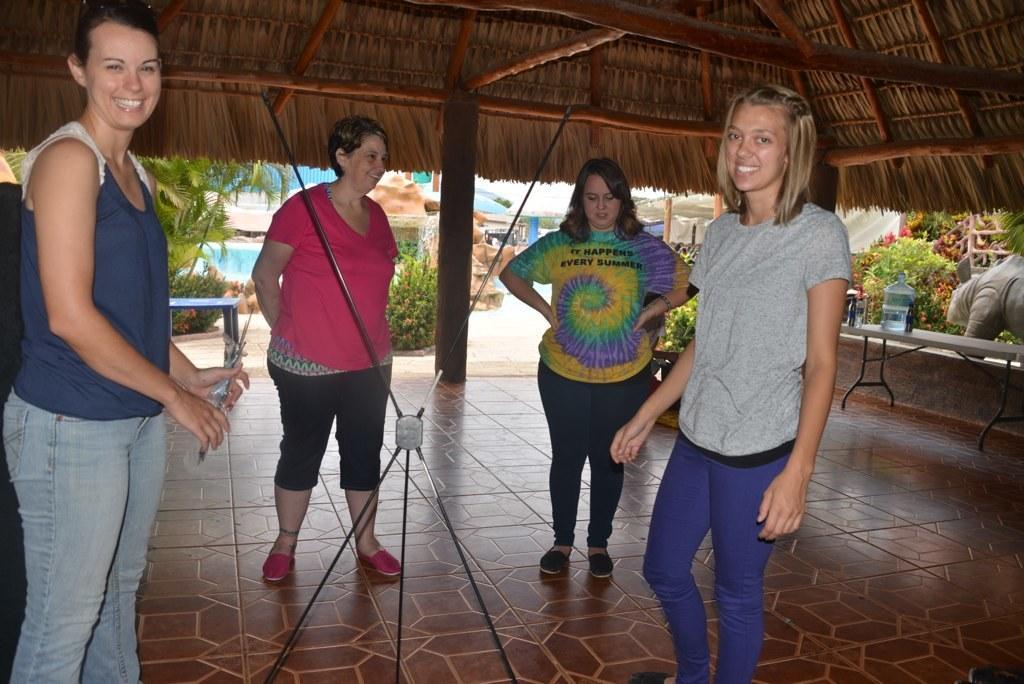Can you describe this image briefly? In the picture we can see four women are standing under the shed and they are smiling and outside the shed we can see some plants and some other houses. 